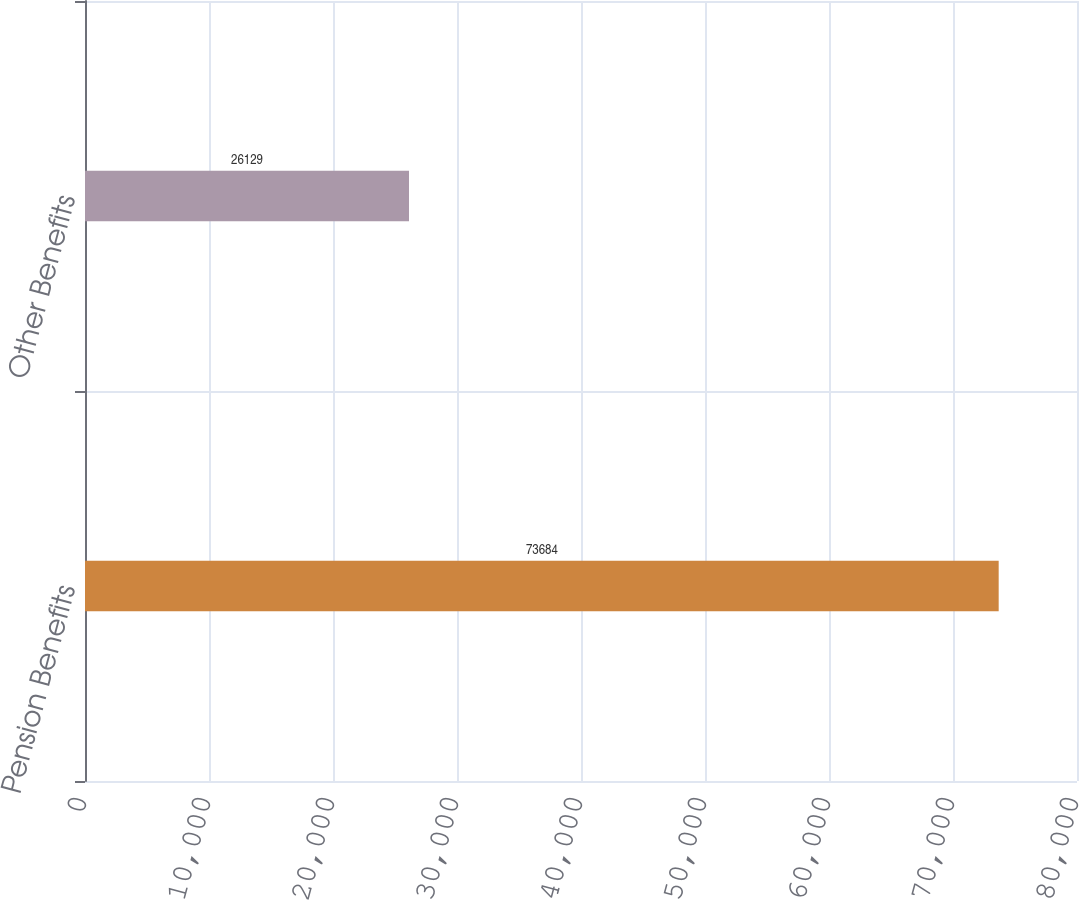Convert chart to OTSL. <chart><loc_0><loc_0><loc_500><loc_500><bar_chart><fcel>Pension Benefits<fcel>Other Benefits<nl><fcel>73684<fcel>26129<nl></chart> 